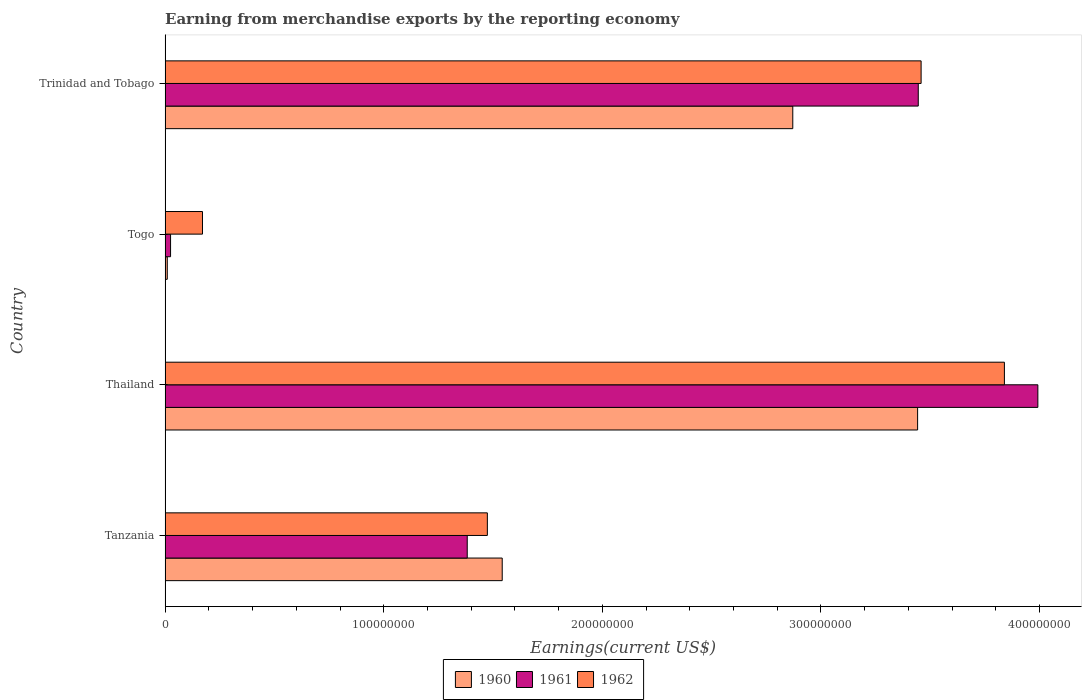How many different coloured bars are there?
Offer a terse response. 3. How many groups of bars are there?
Offer a very short reply. 4. Are the number of bars on each tick of the Y-axis equal?
Ensure brevity in your answer.  Yes. What is the label of the 2nd group of bars from the top?
Provide a short and direct response. Togo. In how many cases, is the number of bars for a given country not equal to the number of legend labels?
Your response must be concise. 0. What is the amount earned from merchandise exports in 1961 in Togo?
Provide a succinct answer. 2.50e+06. Across all countries, what is the maximum amount earned from merchandise exports in 1961?
Provide a succinct answer. 3.99e+08. Across all countries, what is the minimum amount earned from merchandise exports in 1960?
Make the answer very short. 1.00e+06. In which country was the amount earned from merchandise exports in 1961 maximum?
Ensure brevity in your answer.  Thailand. In which country was the amount earned from merchandise exports in 1961 minimum?
Keep it short and to the point. Togo. What is the total amount earned from merchandise exports in 1962 in the graph?
Provide a short and direct response. 8.94e+08. What is the difference between the amount earned from merchandise exports in 1962 in Tanzania and that in Thailand?
Offer a terse response. -2.36e+08. What is the difference between the amount earned from merchandise exports in 1962 in Thailand and the amount earned from merchandise exports in 1960 in Tanzania?
Provide a short and direct response. 2.30e+08. What is the average amount earned from merchandise exports in 1960 per country?
Make the answer very short. 1.97e+08. What is the difference between the amount earned from merchandise exports in 1962 and amount earned from merchandise exports in 1960 in Trinidad and Tobago?
Offer a very short reply. 5.87e+07. What is the ratio of the amount earned from merchandise exports in 1960 in Thailand to that in Trinidad and Tobago?
Give a very brief answer. 1.2. Is the difference between the amount earned from merchandise exports in 1962 in Tanzania and Trinidad and Tobago greater than the difference between the amount earned from merchandise exports in 1960 in Tanzania and Trinidad and Tobago?
Give a very brief answer. No. What is the difference between the highest and the second highest amount earned from merchandise exports in 1961?
Your answer should be compact. 5.47e+07. What is the difference between the highest and the lowest amount earned from merchandise exports in 1960?
Keep it short and to the point. 3.43e+08. In how many countries, is the amount earned from merchandise exports in 1962 greater than the average amount earned from merchandise exports in 1962 taken over all countries?
Offer a terse response. 2. Is it the case that in every country, the sum of the amount earned from merchandise exports in 1960 and amount earned from merchandise exports in 1961 is greater than the amount earned from merchandise exports in 1962?
Your response must be concise. No. How many countries are there in the graph?
Your answer should be compact. 4. How are the legend labels stacked?
Make the answer very short. Horizontal. What is the title of the graph?
Provide a succinct answer. Earning from merchandise exports by the reporting economy. Does "2001" appear as one of the legend labels in the graph?
Provide a succinct answer. No. What is the label or title of the X-axis?
Offer a terse response. Earnings(current US$). What is the Earnings(current US$) in 1960 in Tanzania?
Provide a short and direct response. 1.54e+08. What is the Earnings(current US$) of 1961 in Tanzania?
Ensure brevity in your answer.  1.38e+08. What is the Earnings(current US$) in 1962 in Tanzania?
Give a very brief answer. 1.47e+08. What is the Earnings(current US$) in 1960 in Thailand?
Provide a short and direct response. 3.44e+08. What is the Earnings(current US$) of 1961 in Thailand?
Provide a short and direct response. 3.99e+08. What is the Earnings(current US$) in 1962 in Thailand?
Ensure brevity in your answer.  3.84e+08. What is the Earnings(current US$) in 1960 in Togo?
Offer a terse response. 1.00e+06. What is the Earnings(current US$) of 1961 in Togo?
Your answer should be compact. 2.50e+06. What is the Earnings(current US$) of 1962 in Togo?
Make the answer very short. 1.71e+07. What is the Earnings(current US$) of 1960 in Trinidad and Tobago?
Your answer should be compact. 2.87e+08. What is the Earnings(current US$) of 1961 in Trinidad and Tobago?
Your response must be concise. 3.44e+08. What is the Earnings(current US$) of 1962 in Trinidad and Tobago?
Offer a terse response. 3.46e+08. Across all countries, what is the maximum Earnings(current US$) in 1960?
Offer a terse response. 3.44e+08. Across all countries, what is the maximum Earnings(current US$) in 1961?
Provide a short and direct response. 3.99e+08. Across all countries, what is the maximum Earnings(current US$) in 1962?
Make the answer very short. 3.84e+08. Across all countries, what is the minimum Earnings(current US$) of 1960?
Your response must be concise. 1.00e+06. Across all countries, what is the minimum Earnings(current US$) of 1961?
Make the answer very short. 2.50e+06. Across all countries, what is the minimum Earnings(current US$) in 1962?
Give a very brief answer. 1.71e+07. What is the total Earnings(current US$) of 1960 in the graph?
Give a very brief answer. 7.86e+08. What is the total Earnings(current US$) of 1961 in the graph?
Provide a succinct answer. 8.84e+08. What is the total Earnings(current US$) in 1962 in the graph?
Provide a succinct answer. 8.94e+08. What is the difference between the Earnings(current US$) in 1960 in Tanzania and that in Thailand?
Your answer should be compact. -1.90e+08. What is the difference between the Earnings(current US$) in 1961 in Tanzania and that in Thailand?
Offer a very short reply. -2.61e+08. What is the difference between the Earnings(current US$) in 1962 in Tanzania and that in Thailand?
Give a very brief answer. -2.36e+08. What is the difference between the Earnings(current US$) of 1960 in Tanzania and that in Togo?
Give a very brief answer. 1.53e+08. What is the difference between the Earnings(current US$) in 1961 in Tanzania and that in Togo?
Ensure brevity in your answer.  1.36e+08. What is the difference between the Earnings(current US$) of 1962 in Tanzania and that in Togo?
Ensure brevity in your answer.  1.30e+08. What is the difference between the Earnings(current US$) of 1960 in Tanzania and that in Trinidad and Tobago?
Offer a very short reply. -1.33e+08. What is the difference between the Earnings(current US$) in 1961 in Tanzania and that in Trinidad and Tobago?
Your answer should be very brief. -2.06e+08. What is the difference between the Earnings(current US$) of 1962 in Tanzania and that in Trinidad and Tobago?
Give a very brief answer. -1.98e+08. What is the difference between the Earnings(current US$) in 1960 in Thailand and that in Togo?
Ensure brevity in your answer.  3.43e+08. What is the difference between the Earnings(current US$) of 1961 in Thailand and that in Togo?
Your answer should be compact. 3.97e+08. What is the difference between the Earnings(current US$) in 1962 in Thailand and that in Togo?
Your response must be concise. 3.67e+08. What is the difference between the Earnings(current US$) of 1960 in Thailand and that in Trinidad and Tobago?
Keep it short and to the point. 5.71e+07. What is the difference between the Earnings(current US$) of 1961 in Thailand and that in Trinidad and Tobago?
Give a very brief answer. 5.47e+07. What is the difference between the Earnings(current US$) in 1962 in Thailand and that in Trinidad and Tobago?
Make the answer very short. 3.81e+07. What is the difference between the Earnings(current US$) in 1960 in Togo and that in Trinidad and Tobago?
Provide a short and direct response. -2.86e+08. What is the difference between the Earnings(current US$) in 1961 in Togo and that in Trinidad and Tobago?
Your response must be concise. -3.42e+08. What is the difference between the Earnings(current US$) in 1962 in Togo and that in Trinidad and Tobago?
Provide a short and direct response. -3.29e+08. What is the difference between the Earnings(current US$) in 1960 in Tanzania and the Earnings(current US$) in 1961 in Thailand?
Your answer should be compact. -2.45e+08. What is the difference between the Earnings(current US$) in 1960 in Tanzania and the Earnings(current US$) in 1962 in Thailand?
Keep it short and to the point. -2.30e+08. What is the difference between the Earnings(current US$) in 1961 in Tanzania and the Earnings(current US$) in 1962 in Thailand?
Your answer should be very brief. -2.46e+08. What is the difference between the Earnings(current US$) of 1960 in Tanzania and the Earnings(current US$) of 1961 in Togo?
Offer a terse response. 1.52e+08. What is the difference between the Earnings(current US$) of 1960 in Tanzania and the Earnings(current US$) of 1962 in Togo?
Ensure brevity in your answer.  1.37e+08. What is the difference between the Earnings(current US$) in 1961 in Tanzania and the Earnings(current US$) in 1962 in Togo?
Give a very brief answer. 1.21e+08. What is the difference between the Earnings(current US$) of 1960 in Tanzania and the Earnings(current US$) of 1961 in Trinidad and Tobago?
Keep it short and to the point. -1.90e+08. What is the difference between the Earnings(current US$) in 1960 in Tanzania and the Earnings(current US$) in 1962 in Trinidad and Tobago?
Offer a very short reply. -1.92e+08. What is the difference between the Earnings(current US$) in 1961 in Tanzania and the Earnings(current US$) in 1962 in Trinidad and Tobago?
Provide a succinct answer. -2.08e+08. What is the difference between the Earnings(current US$) in 1960 in Thailand and the Earnings(current US$) in 1961 in Togo?
Make the answer very short. 3.42e+08. What is the difference between the Earnings(current US$) in 1960 in Thailand and the Earnings(current US$) in 1962 in Togo?
Make the answer very short. 3.27e+08. What is the difference between the Earnings(current US$) in 1961 in Thailand and the Earnings(current US$) in 1962 in Togo?
Offer a very short reply. 3.82e+08. What is the difference between the Earnings(current US$) of 1960 in Thailand and the Earnings(current US$) of 1962 in Trinidad and Tobago?
Keep it short and to the point. -1.60e+06. What is the difference between the Earnings(current US$) of 1961 in Thailand and the Earnings(current US$) of 1962 in Trinidad and Tobago?
Offer a terse response. 5.34e+07. What is the difference between the Earnings(current US$) in 1960 in Togo and the Earnings(current US$) in 1961 in Trinidad and Tobago?
Make the answer very short. -3.44e+08. What is the difference between the Earnings(current US$) of 1960 in Togo and the Earnings(current US$) of 1962 in Trinidad and Tobago?
Offer a terse response. -3.45e+08. What is the difference between the Earnings(current US$) of 1961 in Togo and the Earnings(current US$) of 1962 in Trinidad and Tobago?
Offer a terse response. -3.43e+08. What is the average Earnings(current US$) of 1960 per country?
Ensure brevity in your answer.  1.97e+08. What is the average Earnings(current US$) in 1961 per country?
Provide a succinct answer. 2.21e+08. What is the average Earnings(current US$) of 1962 per country?
Your response must be concise. 2.24e+08. What is the difference between the Earnings(current US$) of 1960 and Earnings(current US$) of 1961 in Tanzania?
Provide a short and direct response. 1.60e+07. What is the difference between the Earnings(current US$) in 1960 and Earnings(current US$) in 1962 in Tanzania?
Your response must be concise. 6.80e+06. What is the difference between the Earnings(current US$) of 1961 and Earnings(current US$) of 1962 in Tanzania?
Offer a very short reply. -9.20e+06. What is the difference between the Earnings(current US$) in 1960 and Earnings(current US$) in 1961 in Thailand?
Your answer should be compact. -5.50e+07. What is the difference between the Earnings(current US$) in 1960 and Earnings(current US$) in 1962 in Thailand?
Your response must be concise. -3.97e+07. What is the difference between the Earnings(current US$) in 1961 and Earnings(current US$) in 1962 in Thailand?
Make the answer very short. 1.53e+07. What is the difference between the Earnings(current US$) in 1960 and Earnings(current US$) in 1961 in Togo?
Your answer should be very brief. -1.50e+06. What is the difference between the Earnings(current US$) in 1960 and Earnings(current US$) in 1962 in Togo?
Offer a terse response. -1.61e+07. What is the difference between the Earnings(current US$) of 1961 and Earnings(current US$) of 1962 in Togo?
Ensure brevity in your answer.  -1.46e+07. What is the difference between the Earnings(current US$) in 1960 and Earnings(current US$) in 1961 in Trinidad and Tobago?
Give a very brief answer. -5.74e+07. What is the difference between the Earnings(current US$) of 1960 and Earnings(current US$) of 1962 in Trinidad and Tobago?
Offer a terse response. -5.87e+07. What is the difference between the Earnings(current US$) in 1961 and Earnings(current US$) in 1962 in Trinidad and Tobago?
Offer a very short reply. -1.30e+06. What is the ratio of the Earnings(current US$) in 1960 in Tanzania to that in Thailand?
Offer a terse response. 0.45. What is the ratio of the Earnings(current US$) of 1961 in Tanzania to that in Thailand?
Provide a short and direct response. 0.35. What is the ratio of the Earnings(current US$) in 1962 in Tanzania to that in Thailand?
Offer a terse response. 0.38. What is the ratio of the Earnings(current US$) of 1960 in Tanzania to that in Togo?
Your answer should be very brief. 154.2. What is the ratio of the Earnings(current US$) in 1961 in Tanzania to that in Togo?
Offer a very short reply. 55.28. What is the ratio of the Earnings(current US$) of 1962 in Tanzania to that in Togo?
Your response must be concise. 8.62. What is the ratio of the Earnings(current US$) of 1960 in Tanzania to that in Trinidad and Tobago?
Make the answer very short. 0.54. What is the ratio of the Earnings(current US$) in 1961 in Tanzania to that in Trinidad and Tobago?
Provide a succinct answer. 0.4. What is the ratio of the Earnings(current US$) of 1962 in Tanzania to that in Trinidad and Tobago?
Offer a very short reply. 0.43. What is the ratio of the Earnings(current US$) in 1960 in Thailand to that in Togo?
Ensure brevity in your answer.  344.2. What is the ratio of the Earnings(current US$) of 1961 in Thailand to that in Togo?
Offer a terse response. 159.68. What is the ratio of the Earnings(current US$) in 1962 in Thailand to that in Togo?
Give a very brief answer. 22.45. What is the ratio of the Earnings(current US$) of 1960 in Thailand to that in Trinidad and Tobago?
Keep it short and to the point. 1.2. What is the ratio of the Earnings(current US$) of 1961 in Thailand to that in Trinidad and Tobago?
Make the answer very short. 1.16. What is the ratio of the Earnings(current US$) in 1962 in Thailand to that in Trinidad and Tobago?
Your response must be concise. 1.11. What is the ratio of the Earnings(current US$) of 1960 in Togo to that in Trinidad and Tobago?
Your response must be concise. 0. What is the ratio of the Earnings(current US$) of 1961 in Togo to that in Trinidad and Tobago?
Keep it short and to the point. 0.01. What is the ratio of the Earnings(current US$) of 1962 in Togo to that in Trinidad and Tobago?
Keep it short and to the point. 0.05. What is the difference between the highest and the second highest Earnings(current US$) in 1960?
Keep it short and to the point. 5.71e+07. What is the difference between the highest and the second highest Earnings(current US$) in 1961?
Make the answer very short. 5.47e+07. What is the difference between the highest and the second highest Earnings(current US$) of 1962?
Make the answer very short. 3.81e+07. What is the difference between the highest and the lowest Earnings(current US$) of 1960?
Offer a very short reply. 3.43e+08. What is the difference between the highest and the lowest Earnings(current US$) of 1961?
Your answer should be very brief. 3.97e+08. What is the difference between the highest and the lowest Earnings(current US$) of 1962?
Make the answer very short. 3.67e+08. 